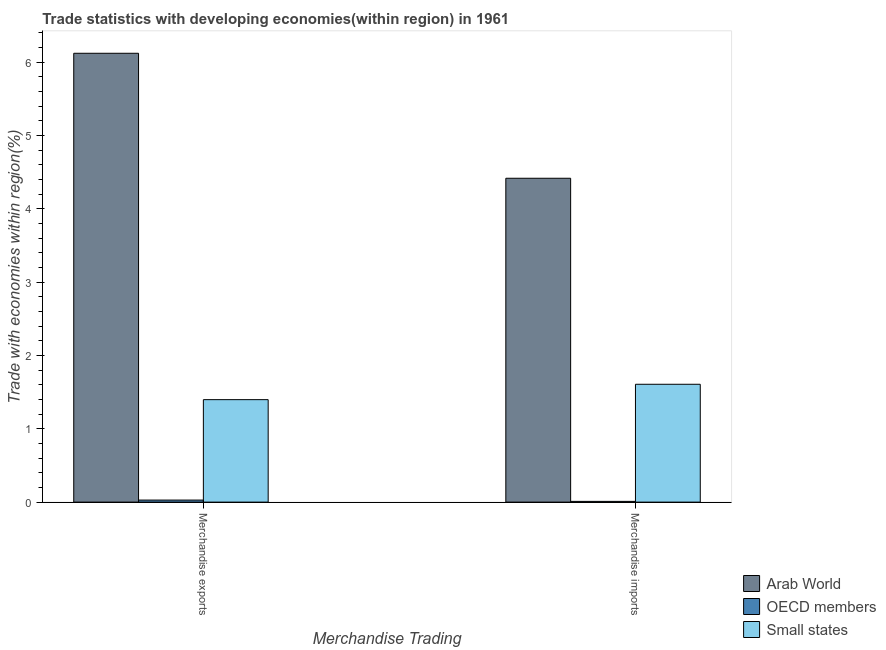How many different coloured bars are there?
Provide a short and direct response. 3. How many groups of bars are there?
Keep it short and to the point. 2. What is the label of the 1st group of bars from the left?
Keep it short and to the point. Merchandise exports. What is the merchandise imports in OECD members?
Ensure brevity in your answer.  0.01. Across all countries, what is the maximum merchandise imports?
Keep it short and to the point. 4.42. Across all countries, what is the minimum merchandise exports?
Offer a very short reply. 0.03. In which country was the merchandise imports maximum?
Keep it short and to the point. Arab World. What is the total merchandise exports in the graph?
Give a very brief answer. 7.55. What is the difference between the merchandise imports in Small states and that in OECD members?
Ensure brevity in your answer.  1.6. What is the difference between the merchandise imports in Small states and the merchandise exports in OECD members?
Ensure brevity in your answer.  1.58. What is the average merchandise imports per country?
Provide a short and direct response. 2.01. What is the difference between the merchandise exports and merchandise imports in OECD members?
Ensure brevity in your answer.  0.02. What is the ratio of the merchandise exports in OECD members to that in Arab World?
Provide a short and direct response. 0. What does the 3rd bar from the left in Merchandise exports represents?
Your answer should be compact. Small states. What does the 3rd bar from the right in Merchandise exports represents?
Provide a short and direct response. Arab World. How are the legend labels stacked?
Your answer should be compact. Vertical. What is the title of the graph?
Provide a short and direct response. Trade statistics with developing economies(within region) in 1961. What is the label or title of the X-axis?
Provide a short and direct response. Merchandise Trading. What is the label or title of the Y-axis?
Offer a very short reply. Trade with economies within region(%). What is the Trade with economies within region(%) in Arab World in Merchandise exports?
Offer a very short reply. 6.12. What is the Trade with economies within region(%) of OECD members in Merchandise exports?
Offer a very short reply. 0.03. What is the Trade with economies within region(%) of Small states in Merchandise exports?
Keep it short and to the point. 1.4. What is the Trade with economies within region(%) in Arab World in Merchandise imports?
Make the answer very short. 4.42. What is the Trade with economies within region(%) of OECD members in Merchandise imports?
Make the answer very short. 0.01. What is the Trade with economies within region(%) in Small states in Merchandise imports?
Keep it short and to the point. 1.61. Across all Merchandise Trading, what is the maximum Trade with economies within region(%) of Arab World?
Keep it short and to the point. 6.12. Across all Merchandise Trading, what is the maximum Trade with economies within region(%) in OECD members?
Provide a short and direct response. 0.03. Across all Merchandise Trading, what is the maximum Trade with economies within region(%) of Small states?
Give a very brief answer. 1.61. Across all Merchandise Trading, what is the minimum Trade with economies within region(%) in Arab World?
Provide a succinct answer. 4.42. Across all Merchandise Trading, what is the minimum Trade with economies within region(%) in OECD members?
Provide a short and direct response. 0.01. Across all Merchandise Trading, what is the minimum Trade with economies within region(%) of Small states?
Offer a terse response. 1.4. What is the total Trade with economies within region(%) of Arab World in the graph?
Provide a succinct answer. 10.54. What is the total Trade with economies within region(%) of OECD members in the graph?
Make the answer very short. 0.04. What is the total Trade with economies within region(%) in Small states in the graph?
Ensure brevity in your answer.  3. What is the difference between the Trade with economies within region(%) of Arab World in Merchandise exports and that in Merchandise imports?
Offer a terse response. 1.7. What is the difference between the Trade with economies within region(%) in OECD members in Merchandise exports and that in Merchandise imports?
Your answer should be very brief. 0.02. What is the difference between the Trade with economies within region(%) of Small states in Merchandise exports and that in Merchandise imports?
Your answer should be compact. -0.21. What is the difference between the Trade with economies within region(%) in Arab World in Merchandise exports and the Trade with economies within region(%) in OECD members in Merchandise imports?
Your response must be concise. 6.11. What is the difference between the Trade with economies within region(%) of Arab World in Merchandise exports and the Trade with economies within region(%) of Small states in Merchandise imports?
Your answer should be very brief. 4.51. What is the difference between the Trade with economies within region(%) in OECD members in Merchandise exports and the Trade with economies within region(%) in Small states in Merchandise imports?
Your answer should be very brief. -1.58. What is the average Trade with economies within region(%) of Arab World per Merchandise Trading?
Give a very brief answer. 5.27. What is the average Trade with economies within region(%) in OECD members per Merchandise Trading?
Make the answer very short. 0.02. What is the average Trade with economies within region(%) of Small states per Merchandise Trading?
Keep it short and to the point. 1.5. What is the difference between the Trade with economies within region(%) of Arab World and Trade with economies within region(%) of OECD members in Merchandise exports?
Ensure brevity in your answer.  6.09. What is the difference between the Trade with economies within region(%) in Arab World and Trade with economies within region(%) in Small states in Merchandise exports?
Keep it short and to the point. 4.72. What is the difference between the Trade with economies within region(%) of OECD members and Trade with economies within region(%) of Small states in Merchandise exports?
Your answer should be compact. -1.37. What is the difference between the Trade with economies within region(%) of Arab World and Trade with economies within region(%) of OECD members in Merchandise imports?
Give a very brief answer. 4.41. What is the difference between the Trade with economies within region(%) in Arab World and Trade with economies within region(%) in Small states in Merchandise imports?
Give a very brief answer. 2.81. What is the difference between the Trade with economies within region(%) of OECD members and Trade with economies within region(%) of Small states in Merchandise imports?
Your answer should be very brief. -1.6. What is the ratio of the Trade with economies within region(%) of Arab World in Merchandise exports to that in Merchandise imports?
Ensure brevity in your answer.  1.39. What is the ratio of the Trade with economies within region(%) of OECD members in Merchandise exports to that in Merchandise imports?
Provide a succinct answer. 2.77. What is the ratio of the Trade with economies within region(%) of Small states in Merchandise exports to that in Merchandise imports?
Offer a terse response. 0.87. What is the difference between the highest and the second highest Trade with economies within region(%) in Arab World?
Offer a very short reply. 1.7. What is the difference between the highest and the second highest Trade with economies within region(%) of OECD members?
Your answer should be compact. 0.02. What is the difference between the highest and the second highest Trade with economies within region(%) of Small states?
Your response must be concise. 0.21. What is the difference between the highest and the lowest Trade with economies within region(%) of Arab World?
Offer a very short reply. 1.7. What is the difference between the highest and the lowest Trade with economies within region(%) of OECD members?
Provide a succinct answer. 0.02. What is the difference between the highest and the lowest Trade with economies within region(%) in Small states?
Keep it short and to the point. 0.21. 